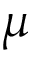Convert formula to latex. <formula><loc_0><loc_0><loc_500><loc_500>\mu</formula> 